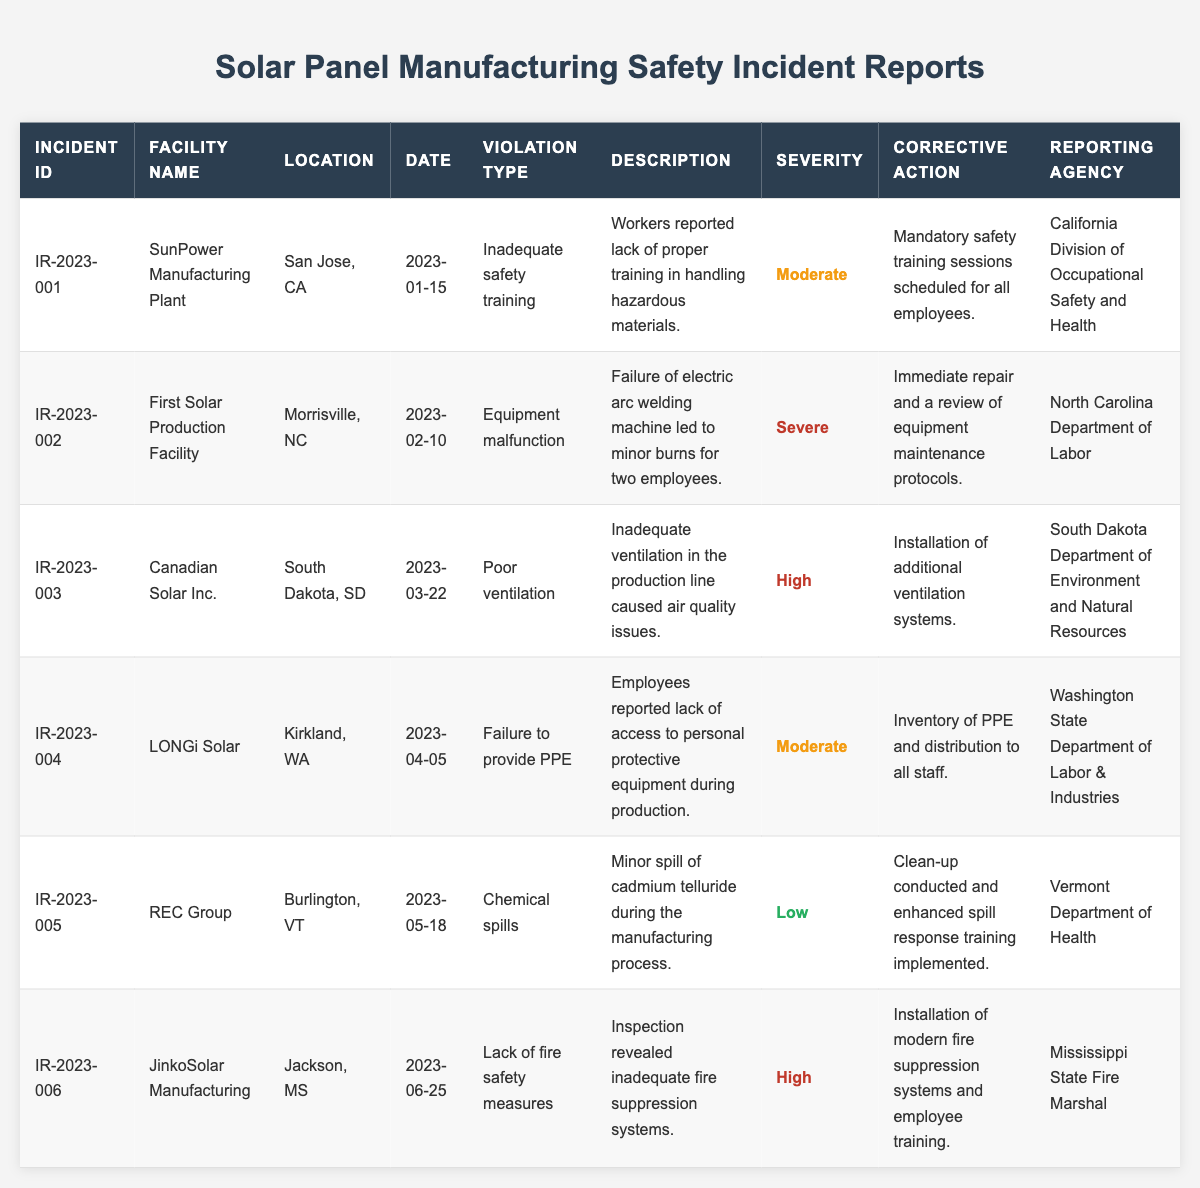What is the most severe violation recorded in the table? The incident with the highest severity is the one noted for the First Solar Production Facility, labeled 'Severe.'
Answer: Severe How many incidents reported involved "Inadequate safety training"? There is 1 incident related to "Inadequate safety training," specifically at the SunPower Manufacturing Plant.
Answer: 1 Which facility had an incident related to chemical spills? The REC Group in Burlington, VT reported an incident regarding chemical spills.
Answer: REC Group What was the corrective action taken for the incident reporting "Lack of fire safety measures"? The corrective action for that incident was the installation of modern fire suppression systems along with employee training.
Answer: Installation of modern fire suppression systems and employee training List the incident IDs that have a severity level classified as "High." The incident IDs with a "High" severity level are IR-2023-003 and IR-2023-006.
Answer: IR-2023-003, IR-2023-006 What corrective actions were taken for incidents with moderate severity? For incidents classified as having moderate severity, the corrective actions were "Mandatory safety training sessions" at SunPower and "Inventory of PPE" at LONGi Solar.
Answer: Mandatory safety training sessions, Inventory of PPE How many incidents occurred in the first half of 2023? There are a total of 6 incidents logged, and all of them occurred in the first half of the year, from January to June 2023.
Answer: 6 What's the location of the incident reported on February 10, 2023? The incident on February 10, 2023, occurred at the First Solar Production Facility, located in Morrisville, NC.
Answer: Morrisville, NC Which reporting agency handled the incident at Canadian Solar Inc.? The incident at Canadian Solar Inc. was reported to the South Dakota Department of Environment and Natural Resources.
Answer: South Dakota Department of Environment and Natural Resources Is there an incident where the violation type was "Failure to provide PPE"? Yes, there is an incident that involves "Failure to provide PPE," which occurred at LONGi Solar.
Answer: Yes What is the average severity level of incidents reported in January and February? To assess the average severity, we first identify severities from both months (Moderate for January and Severe for February). Each severity can be assigned a numerical value (Low=1, Moderate=2, High=3, Severe=4). The average severity is calculated as (2 for January + 4 for February)/2 = 3, which corresponds to High severity level.
Answer: High 